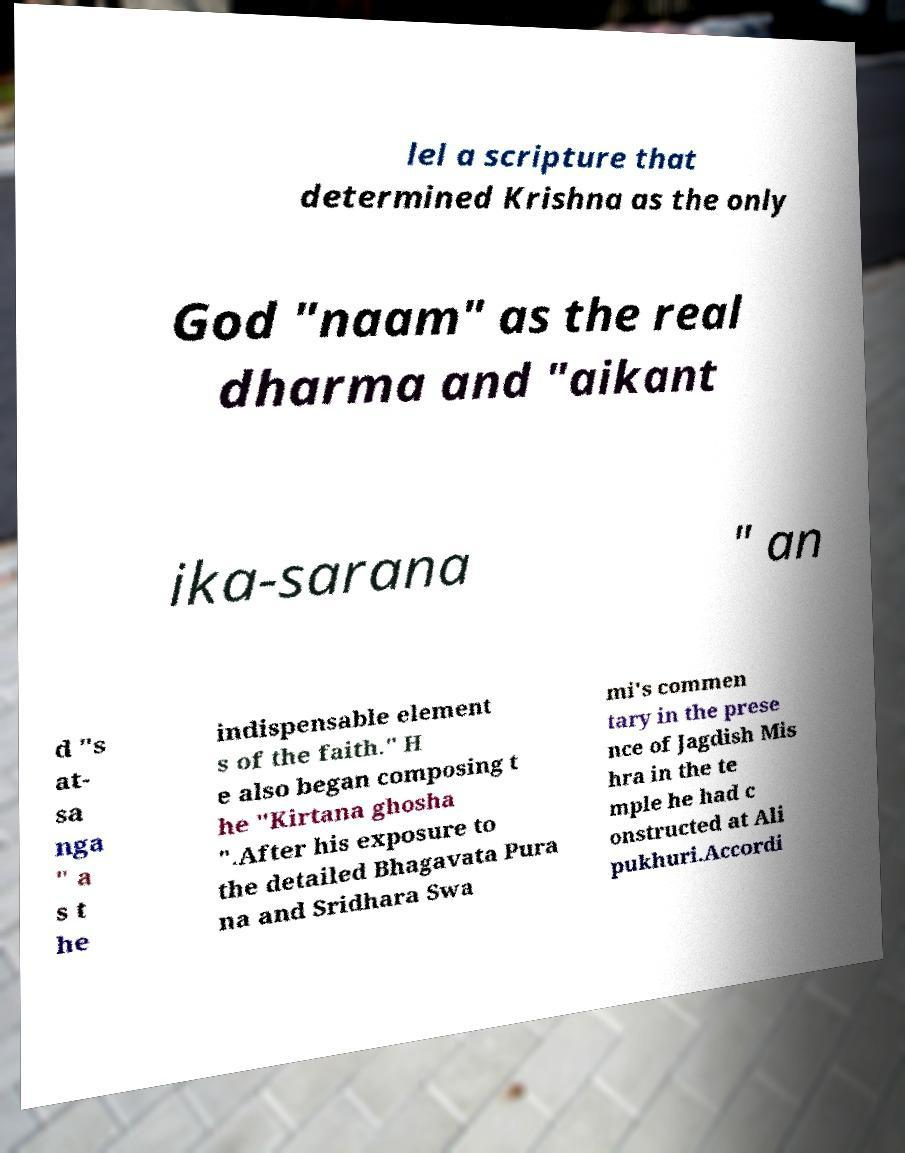Please read and relay the text visible in this image. What does it say? lel a scripture that determined Krishna as the only God "naam" as the real dharma and "aikant ika-sarana " an d "s at- sa nga " a s t he indispensable element s of the faith." H e also began composing t he "Kirtana ghosha ".After his exposure to the detailed Bhagavata Pura na and Sridhara Swa mi's commen tary in the prese nce of Jagdish Mis hra in the te mple he had c onstructed at Ali pukhuri.Accordi 